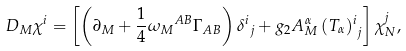Convert formula to latex. <formula><loc_0><loc_0><loc_500><loc_500>D _ { M } \chi ^ { i } = \left [ \left ( \partial _ { M } + \frac { 1 } { 4 } { \omega _ { M } } ^ { A B } \Gamma _ { A B } \right ) { \delta ^ { i } } _ { j } + g _ { 2 } A ^ { \alpha } _ { M } \, { ( T _ { \alpha } ) ^ { i } } _ { j } \right ] \chi ^ { j } _ { N } ,</formula> 